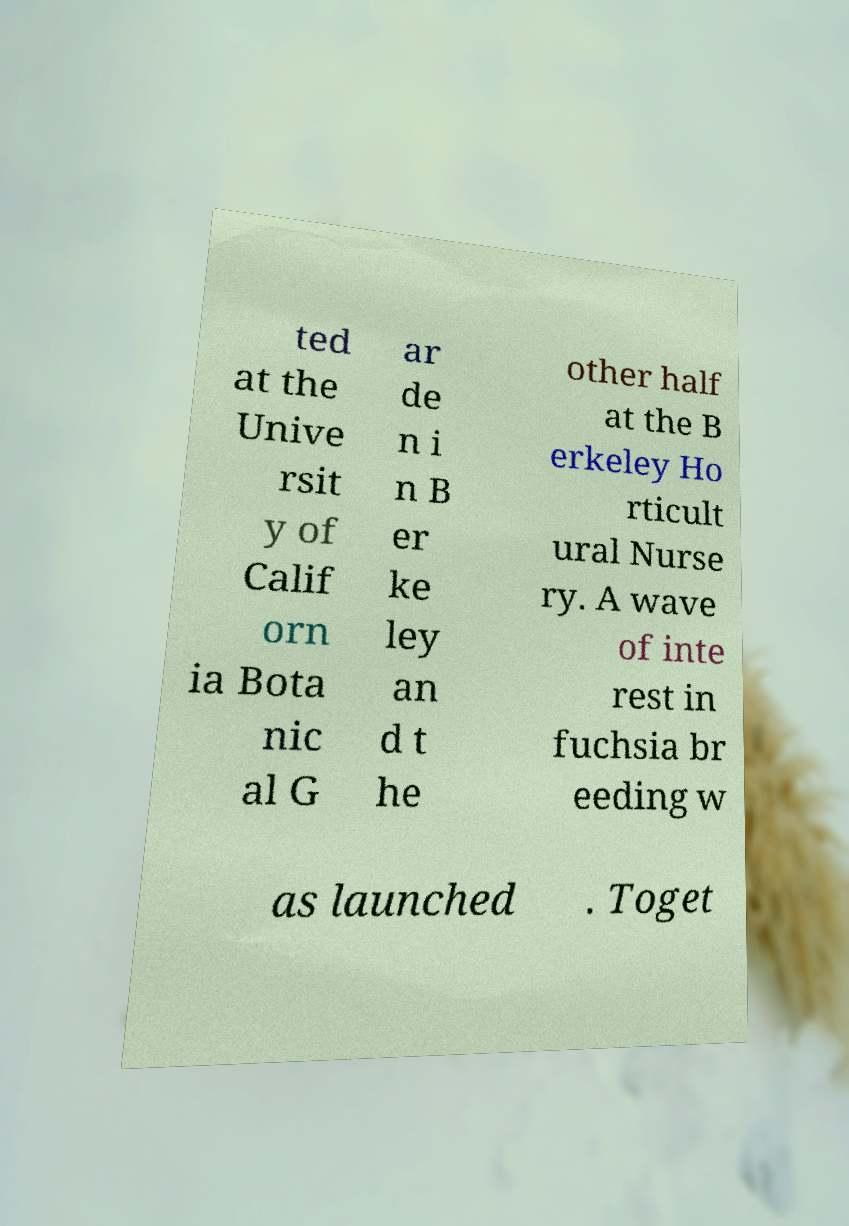Could you extract and type out the text from this image? ted at the Unive rsit y of Calif orn ia Bota nic al G ar de n i n B er ke ley an d t he other half at the B erkeley Ho rticult ural Nurse ry. A wave of inte rest in fuchsia br eeding w as launched . Toget 